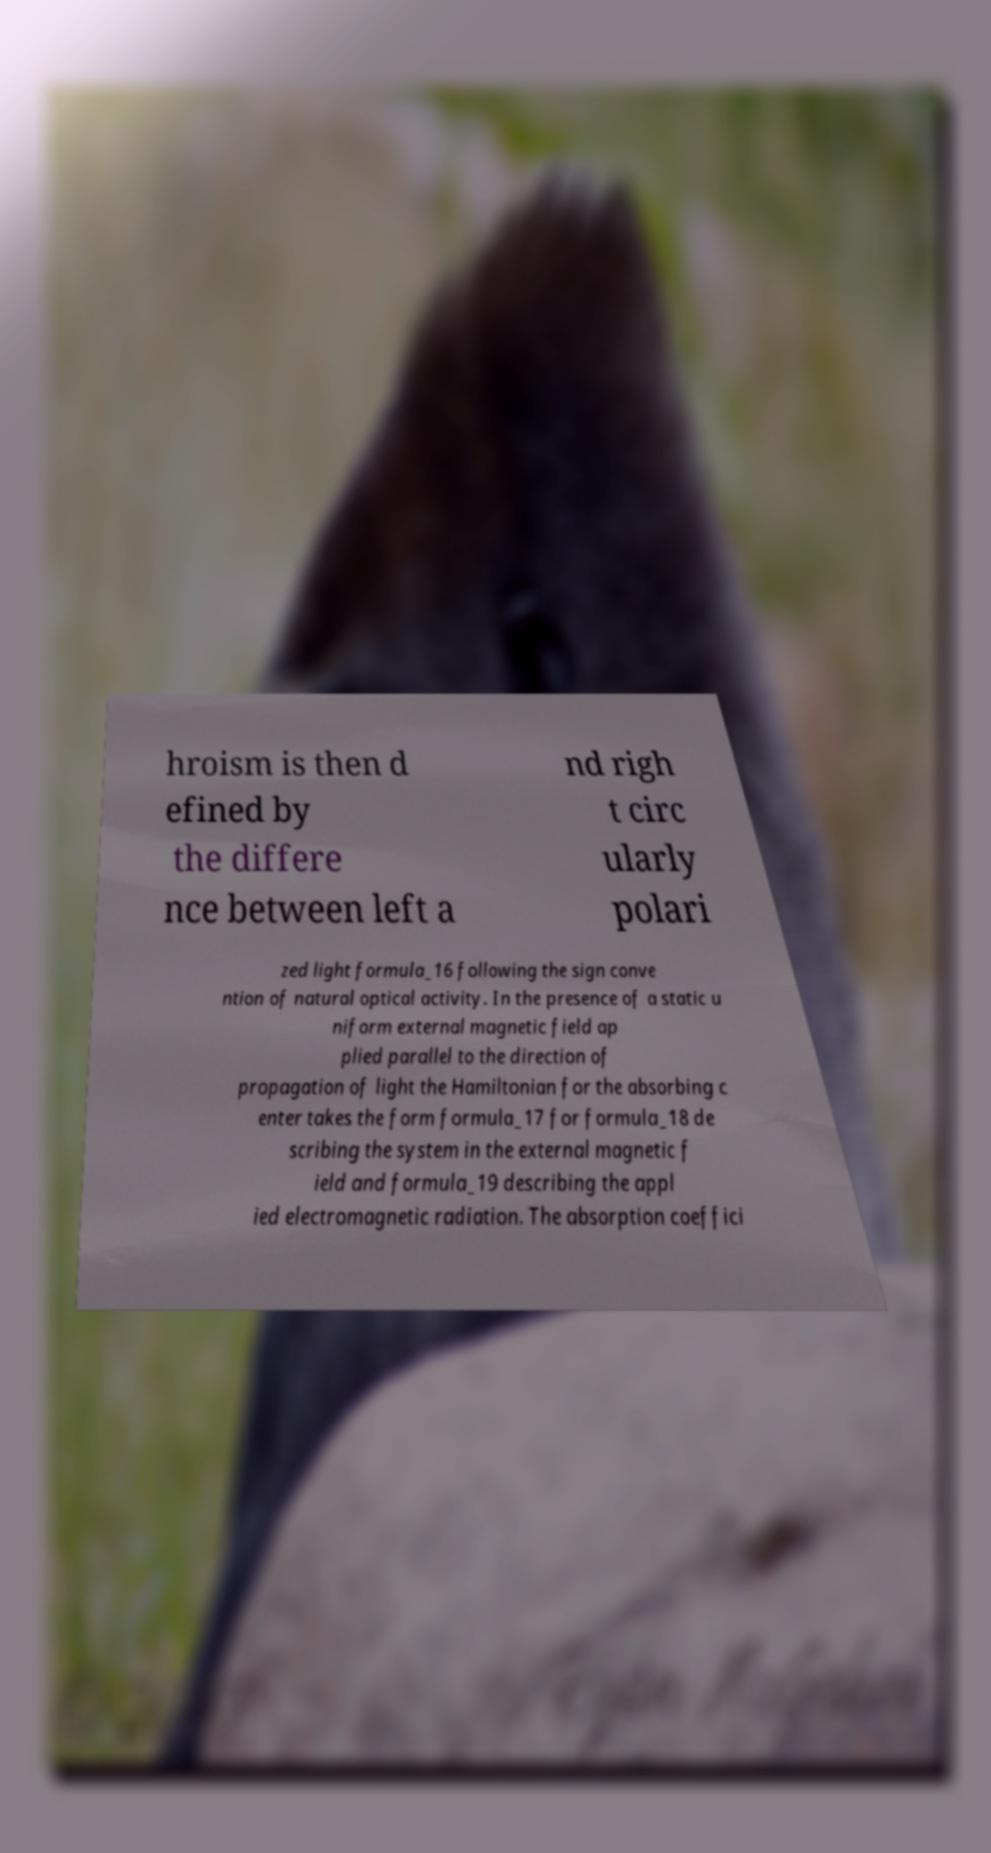Please identify and transcribe the text found in this image. hroism is then d efined by the differe nce between left a nd righ t circ ularly polari zed light formula_16 following the sign conve ntion of natural optical activity. In the presence of a static u niform external magnetic field ap plied parallel to the direction of propagation of light the Hamiltonian for the absorbing c enter takes the form formula_17 for formula_18 de scribing the system in the external magnetic f ield and formula_19 describing the appl ied electromagnetic radiation. The absorption coeffici 